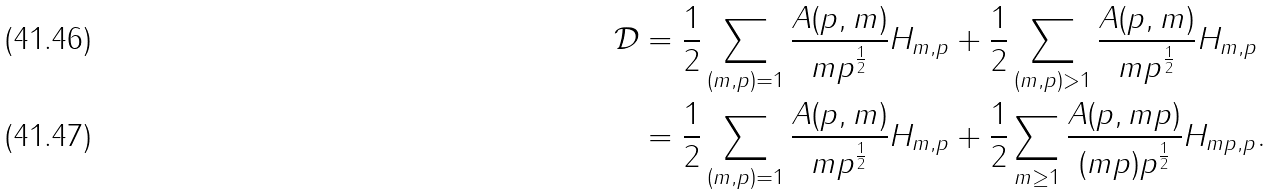Convert formula to latex. <formula><loc_0><loc_0><loc_500><loc_500>\mathcal { D } & = \frac { 1 } { 2 } \sum _ { ( m , p ) = 1 } \frac { A ( p , m ) } { m p ^ { \frac { 1 } { 2 } } } H _ { m , p } + \frac { 1 } { 2 } \sum _ { ( m , p ) > 1 } \frac { A ( p , m ) } { m p ^ { \frac { 1 } { 2 } } } H _ { m , p } \\ & = \frac { 1 } { 2 } \sum _ { ( m , p ) = 1 } \frac { A ( p , m ) } { m p ^ { \frac { 1 } { 2 } } } H _ { m , p } + \frac { 1 } { 2 } \sum _ { m \geq 1 } \frac { A ( p , m p ) } { ( m p ) p ^ { \frac { 1 } { 2 } } } H _ { m p , p } .</formula> 